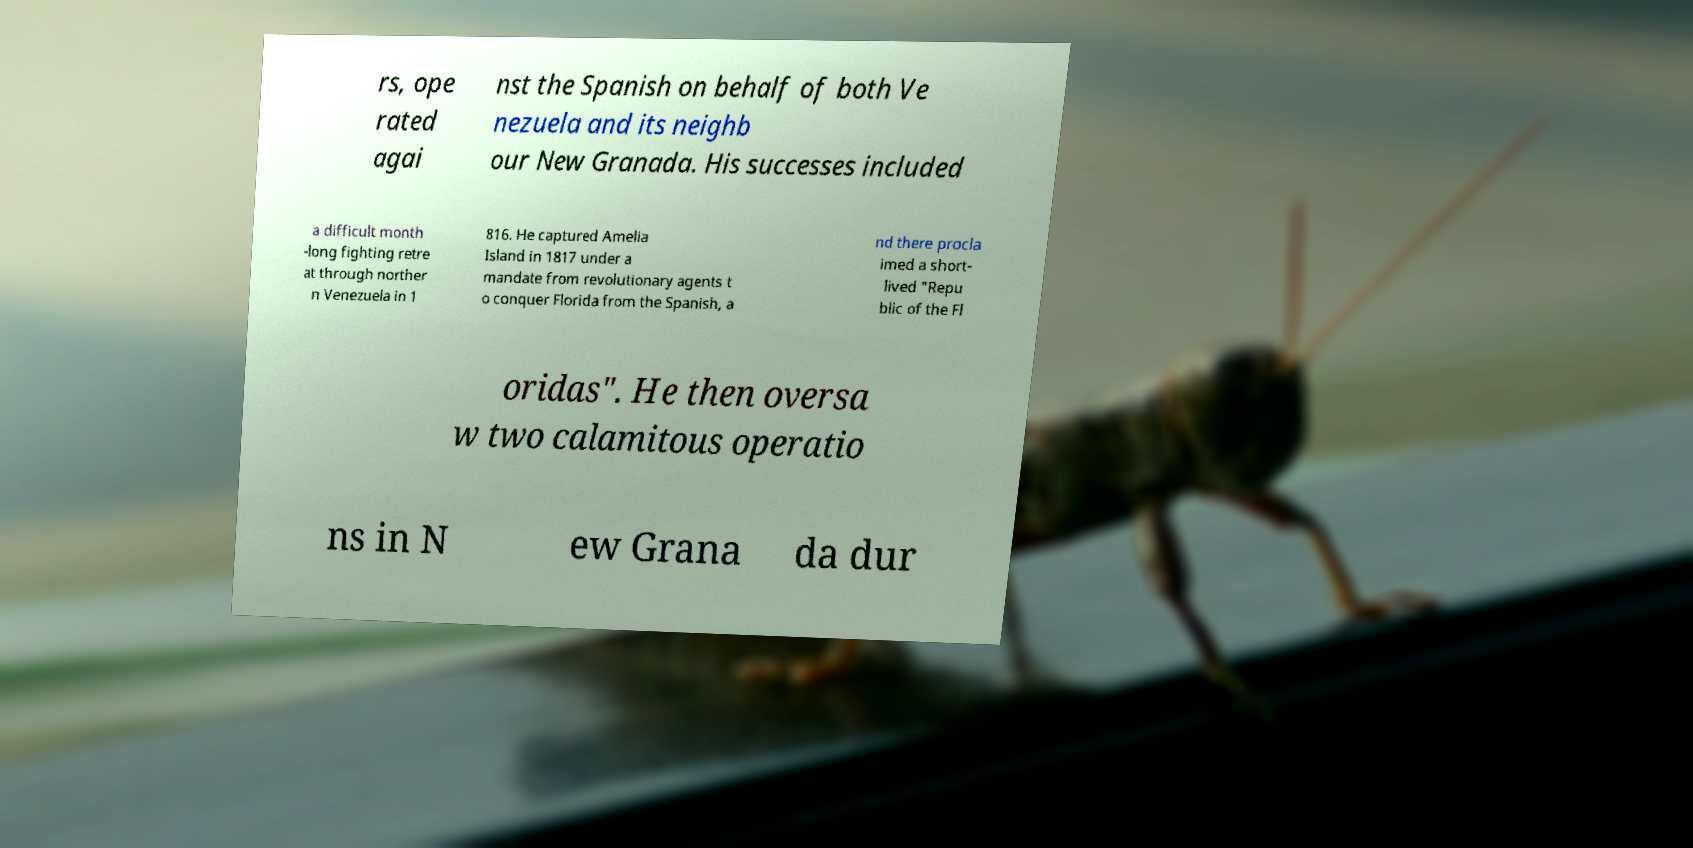Could you assist in decoding the text presented in this image and type it out clearly? rs, ope rated agai nst the Spanish on behalf of both Ve nezuela and its neighb our New Granada. His successes included a difficult month -long fighting retre at through norther n Venezuela in 1 816. He captured Amelia Island in 1817 under a mandate from revolutionary agents t o conquer Florida from the Spanish, a nd there procla imed a short- lived "Repu blic of the Fl oridas". He then oversa w two calamitous operatio ns in N ew Grana da dur 